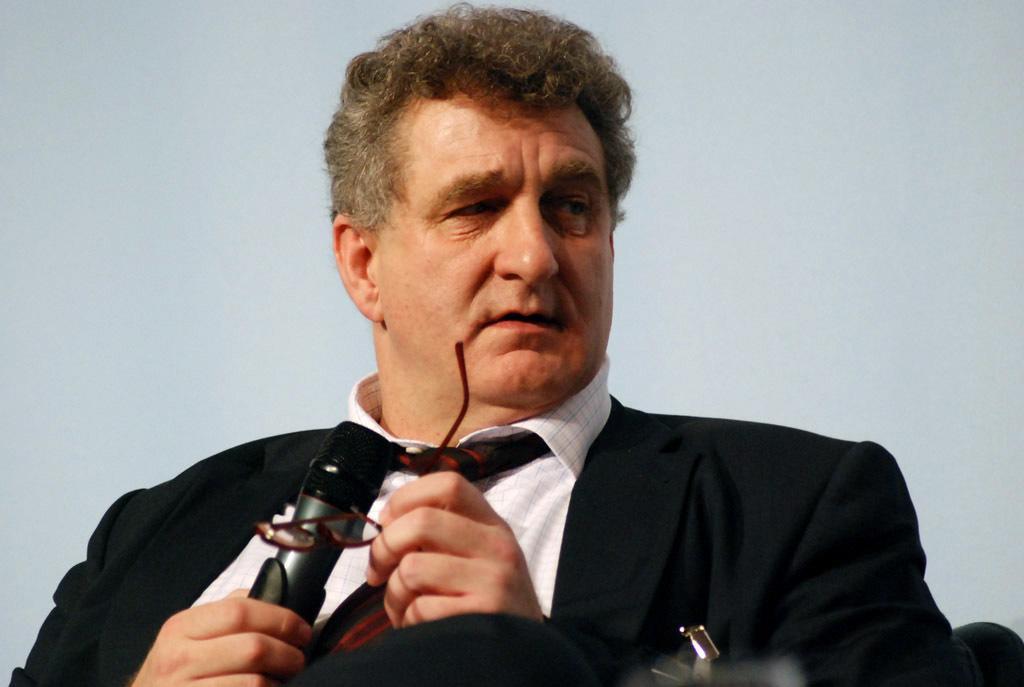Can you describe this image briefly? In this image there is a person wearing black color suit holding microphone and spectacles in his hands. 